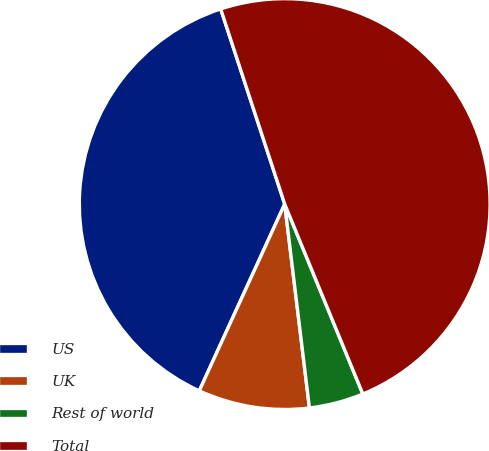Convert chart. <chart><loc_0><loc_0><loc_500><loc_500><pie_chart><fcel>US<fcel>UK<fcel>Rest of world<fcel>Total<nl><fcel>38.12%<fcel>8.75%<fcel>4.29%<fcel>48.83%<nl></chart> 